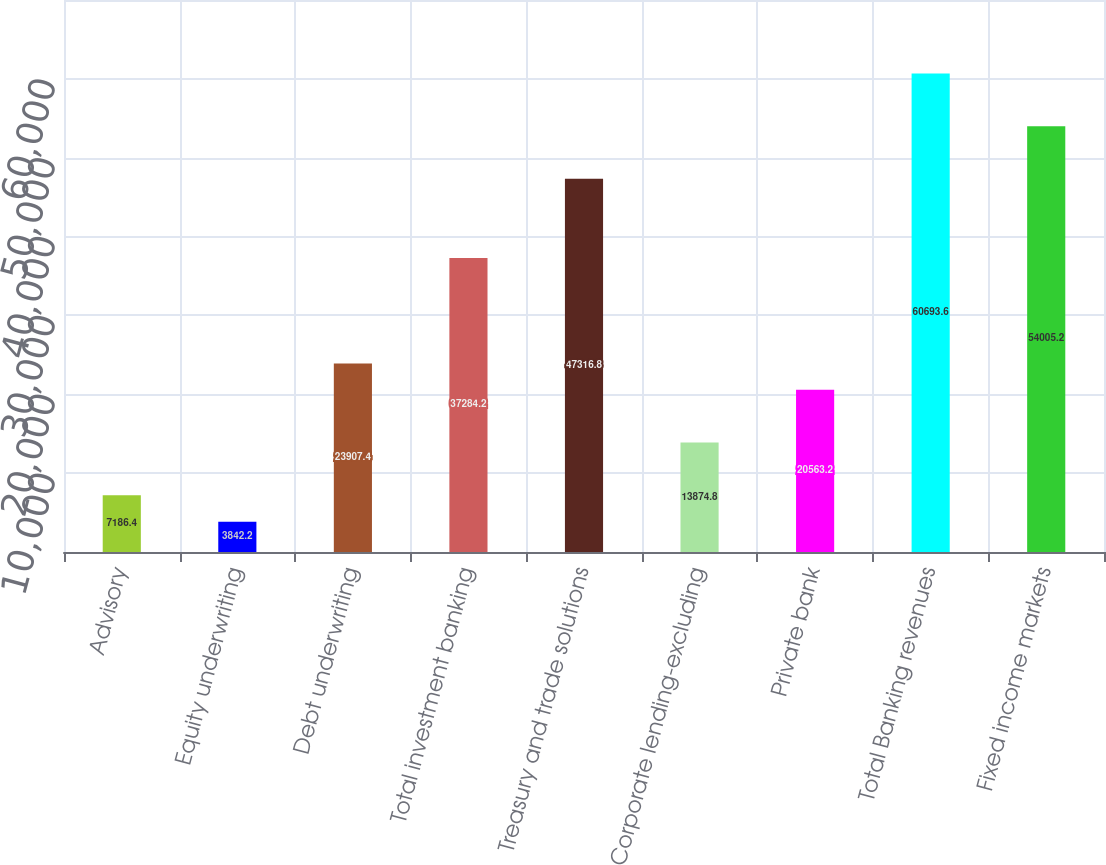<chart> <loc_0><loc_0><loc_500><loc_500><bar_chart><fcel>Advisory<fcel>Equity underwriting<fcel>Debt underwriting<fcel>Total investment banking<fcel>Treasury and trade solutions<fcel>Corporate lending-excluding<fcel>Private bank<fcel>Total Banking revenues<fcel>Fixed income markets<nl><fcel>7186.4<fcel>3842.2<fcel>23907.4<fcel>37284.2<fcel>47316.8<fcel>13874.8<fcel>20563.2<fcel>60693.6<fcel>54005.2<nl></chart> 